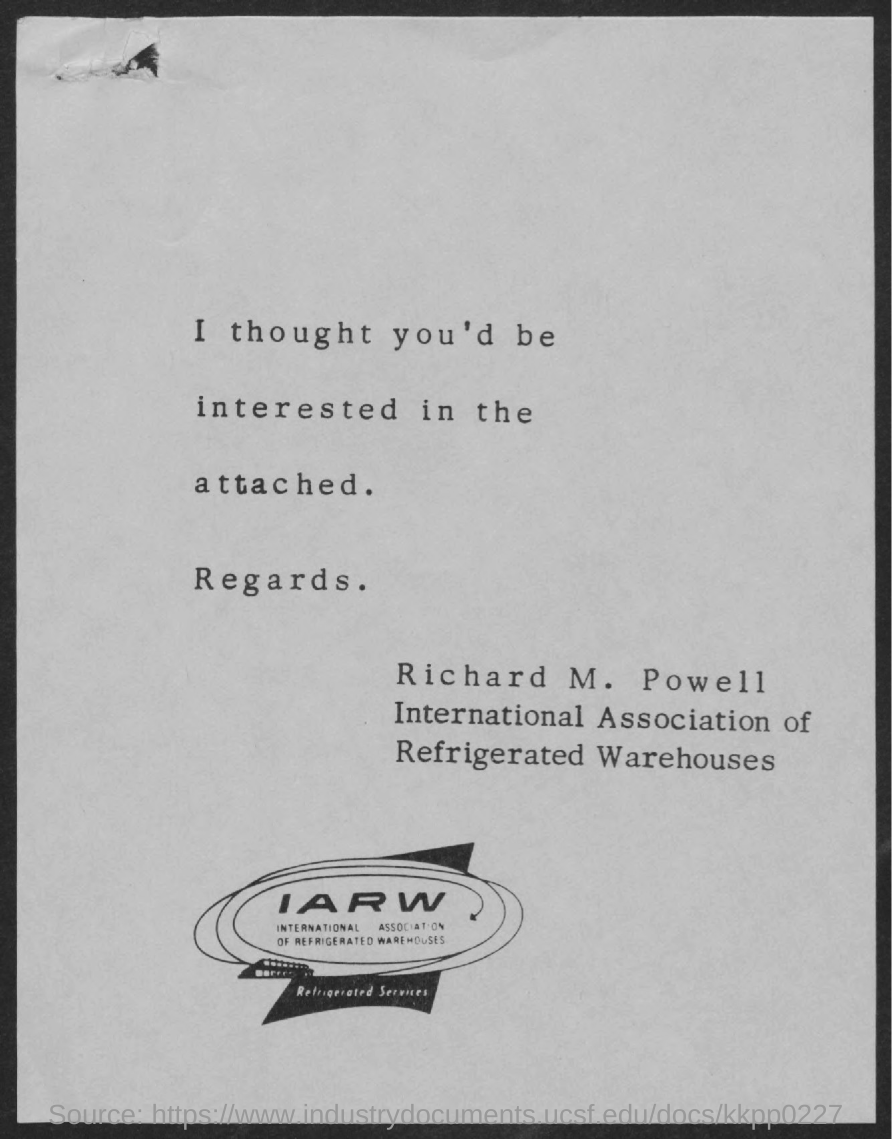Specify some key components in this picture. The full form of IARW is the International Association of Refrigerated Warehouses. 